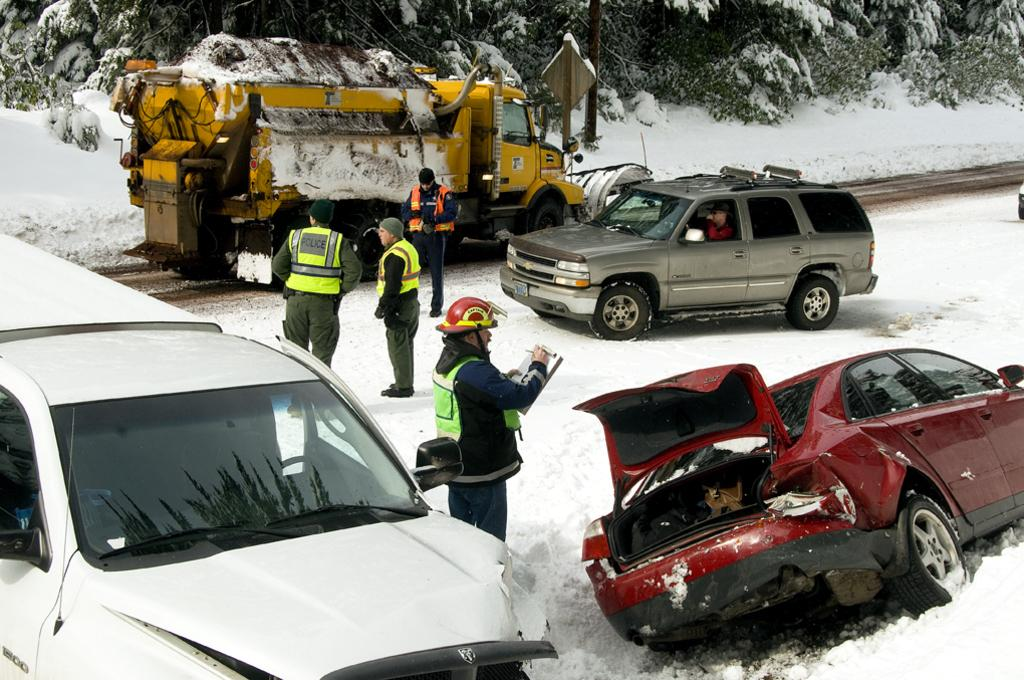What is happening on the snow surface in the foreground area of the image? There are vehicles and people on the snow surface in the foreground area of the image. Can you describe the background of the image? There are trees, a vehicle, and snow visible in the background of the image. What type of ghost can be seen interacting with the wire in the image? There is no ghost or wire present in the image. How many hands are visible on the people in the image? The number of hands visible on the people in the image cannot be determined from the provided facts. 